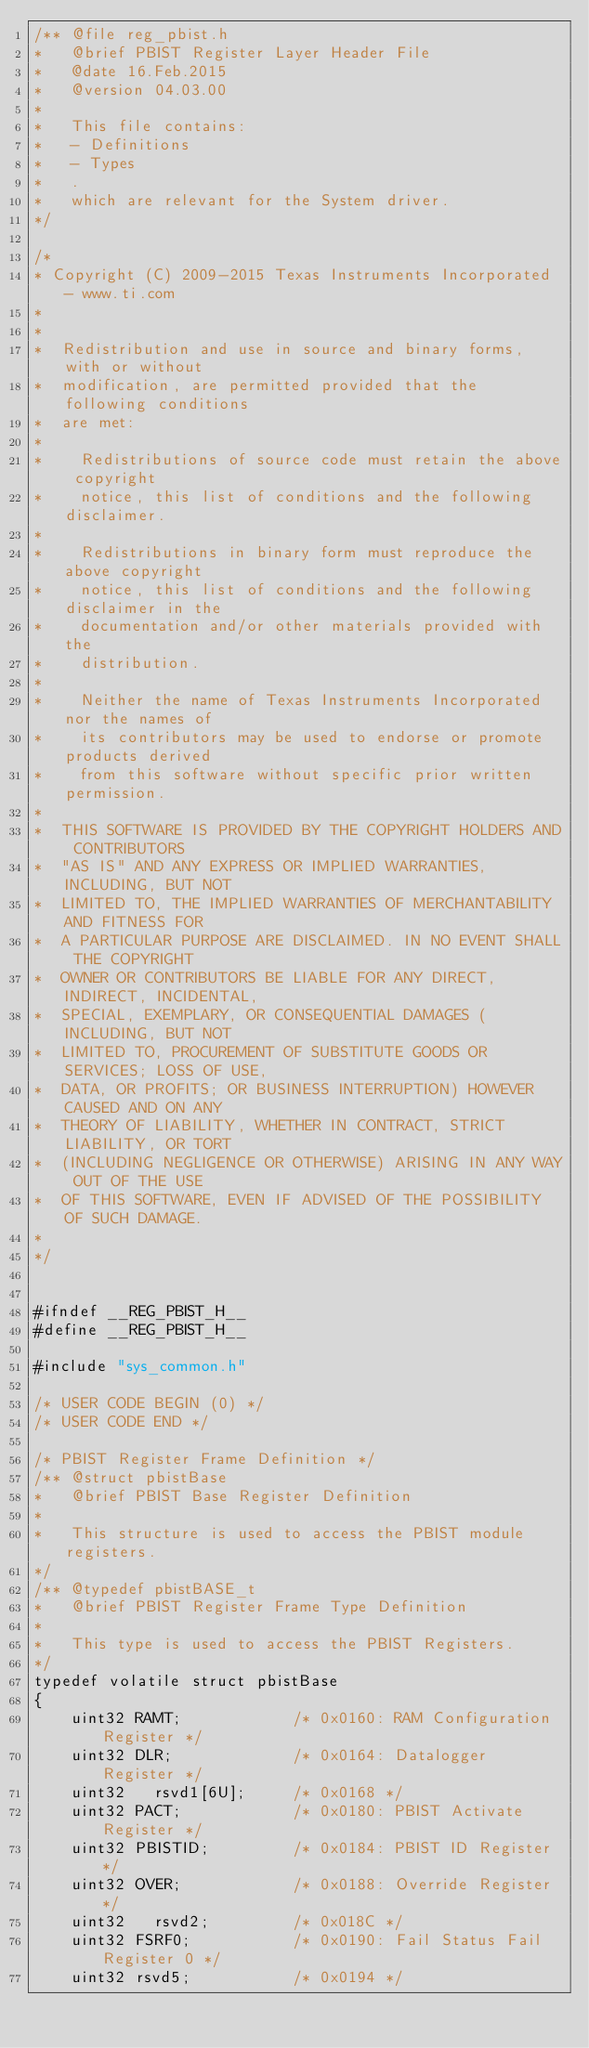Convert code to text. <code><loc_0><loc_0><loc_500><loc_500><_C_>/** @file reg_pbist.h
*   @brief PBIST Register Layer Header File
*   @date 16.Feb.2015
*   @version 04.03.00
*   
*   This file contains:
*   - Definitions
*   - Types
*   .
*   which are relevant for the System driver.
*/

/* 
* Copyright (C) 2009-2015 Texas Instruments Incorporated - www.ti.com 
* 
* 
*  Redistribution and use in source and binary forms, with or without 
*  modification, are permitted provided that the following conditions 
*  are met:
*
*    Redistributions of source code must retain the above copyright 
*    notice, this list of conditions and the following disclaimer.
*
*    Redistributions in binary form must reproduce the above copyright
*    notice, this list of conditions and the following disclaimer in the 
*    documentation and/or other materials provided with the   
*    distribution.
*
*    Neither the name of Texas Instruments Incorporated nor the names of
*    its contributors may be used to endorse or promote products derived
*    from this software without specific prior written permission.
*
*  THIS SOFTWARE IS PROVIDED BY THE COPYRIGHT HOLDERS AND CONTRIBUTORS 
*  "AS IS" AND ANY EXPRESS OR IMPLIED WARRANTIES, INCLUDING, BUT NOT 
*  LIMITED TO, THE IMPLIED WARRANTIES OF MERCHANTABILITY AND FITNESS FOR
*  A PARTICULAR PURPOSE ARE DISCLAIMED. IN NO EVENT SHALL THE COPYRIGHT 
*  OWNER OR CONTRIBUTORS BE LIABLE FOR ANY DIRECT, INDIRECT, INCIDENTAL, 
*  SPECIAL, EXEMPLARY, OR CONSEQUENTIAL DAMAGES (INCLUDING, BUT NOT 
*  LIMITED TO, PROCUREMENT OF SUBSTITUTE GOODS OR SERVICES; LOSS OF USE,
*  DATA, OR PROFITS; OR BUSINESS INTERRUPTION) HOWEVER CAUSED AND ON ANY
*  THEORY OF LIABILITY, WHETHER IN CONTRACT, STRICT LIABILITY, OR TORT 
*  (INCLUDING NEGLIGENCE OR OTHERWISE) ARISING IN ANY WAY OUT OF THE USE 
*  OF THIS SOFTWARE, EVEN IF ADVISED OF THE POSSIBILITY OF SUCH DAMAGE.
*
*/


#ifndef __REG_PBIST_H__
#define __REG_PBIST_H__

#include "sys_common.h"

/* USER CODE BEGIN (0) */
/* USER CODE END */

/* PBIST Register Frame Definition */
/** @struct pbistBase
*   @brief PBIST Base Register Definition
*
*   This structure is used to access the PBIST module registers.
*/
/** @typedef pbistBASE_t
*   @brief PBIST Register Frame Type Definition
*
*   This type is used to access the PBIST Registers.
*/
typedef volatile struct pbistBase
{
    uint32 RAMT;            /* 0x0160: RAM Configuration Register */
    uint32 DLR;             /* 0x0164: Datalogger Register */
    uint32   rsvd1[6U];     /* 0x0168 */
    uint32 PACT;            /* 0x0180: PBIST Activate Register */
    uint32 PBISTID;         /* 0x0184: PBIST ID Register */
    uint32 OVER;            /* 0x0188: Override Register */
    uint32   rsvd2;         /* 0x018C */
    uint32 FSRF0;           /* 0x0190: Fail Status Fail Register 0 */
    uint32 rsvd5;           /* 0x0194 */</code> 